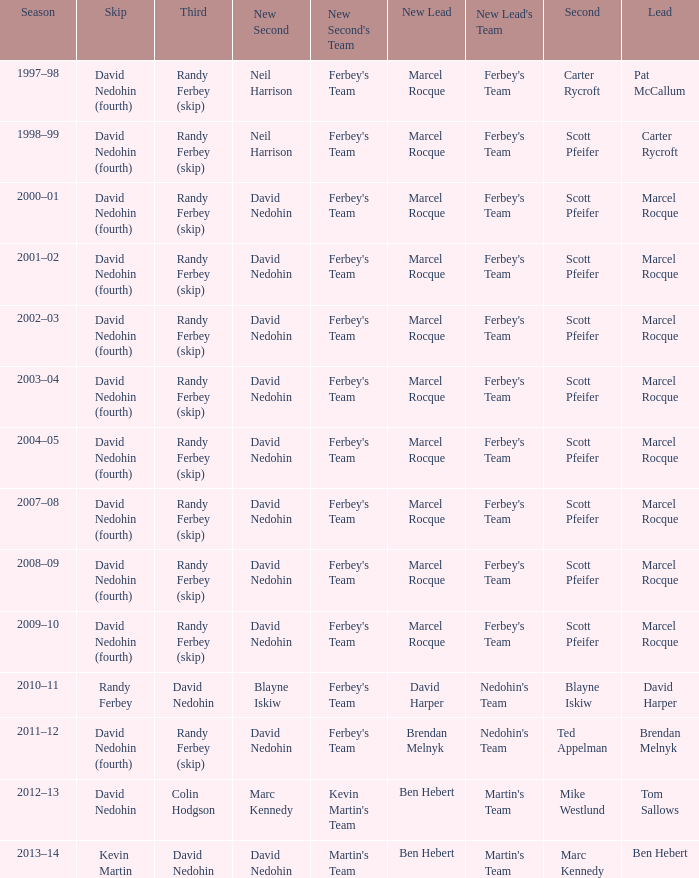Which Second has a Third of david nedohin, and a Lead of ben hebert? Marc Kennedy. 